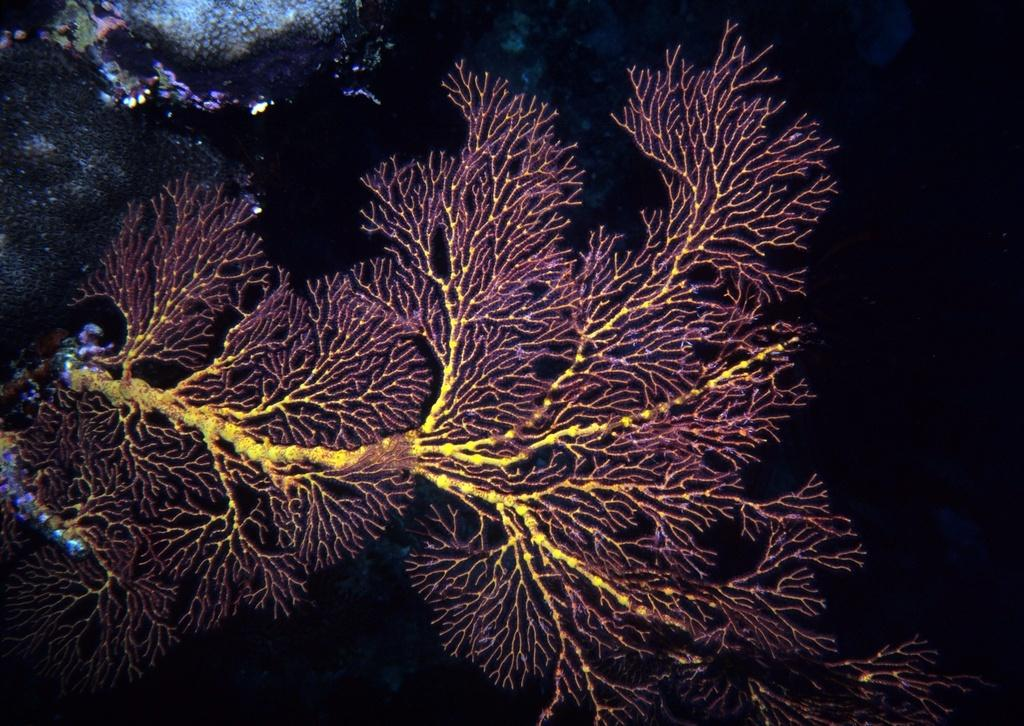What is present in the image? There is a plant in the image. What can be seen on the left side of the image? There are objects in the background on the left side of the image. How would you describe the right side of the image? The right side of the image is dark. What type of fan is visible in the image? There is no fan present in the image. Is there a turkey on the desk in the image? There is no desk or turkey present in the image. 